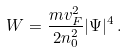Convert formula to latex. <formula><loc_0><loc_0><loc_500><loc_500>W = \frac { m v _ { F } ^ { 2 } } { 2 n _ { 0 } ^ { 2 } } | \Psi | ^ { 4 } \, .</formula> 